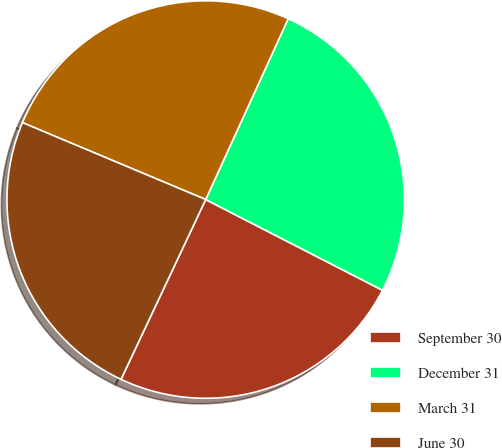Convert chart to OTSL. <chart><loc_0><loc_0><loc_500><loc_500><pie_chart><fcel>September 30<fcel>December 31<fcel>March 31<fcel>June 30<nl><fcel>24.46%<fcel>25.73%<fcel>25.49%<fcel>24.32%<nl></chart> 